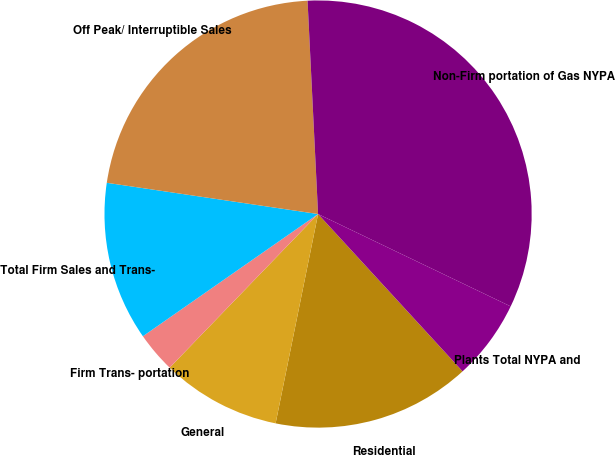Convert chart. <chart><loc_0><loc_0><loc_500><loc_500><pie_chart><fcel>Residential<fcel>General<fcel>Firm Trans- portation<fcel>Total Firm Sales and Trans-<fcel>Off Peak/ Interruptible Sales<fcel>Non-Firm portation of Gas NYPA<fcel>Plants Total NYPA and<nl><fcel>15.01%<fcel>9.04%<fcel>3.08%<fcel>12.03%<fcel>21.88%<fcel>32.9%<fcel>6.06%<nl></chart> 